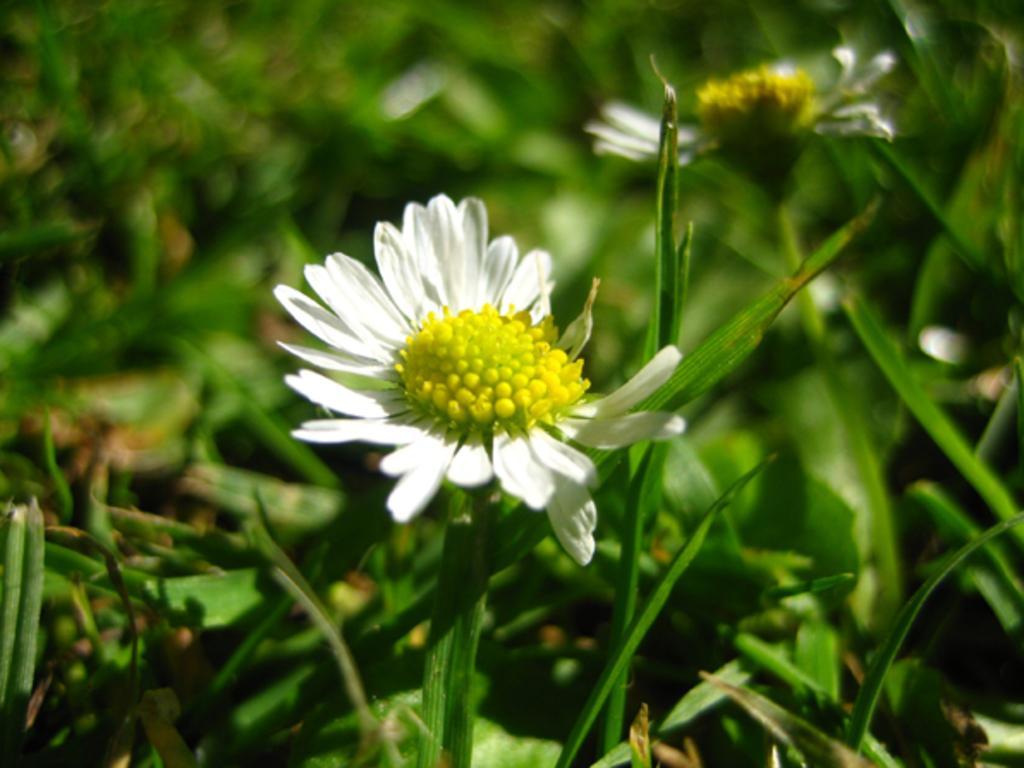How would you summarize this image in a sentence or two? In this image there are flowers and in the background there are plants. 